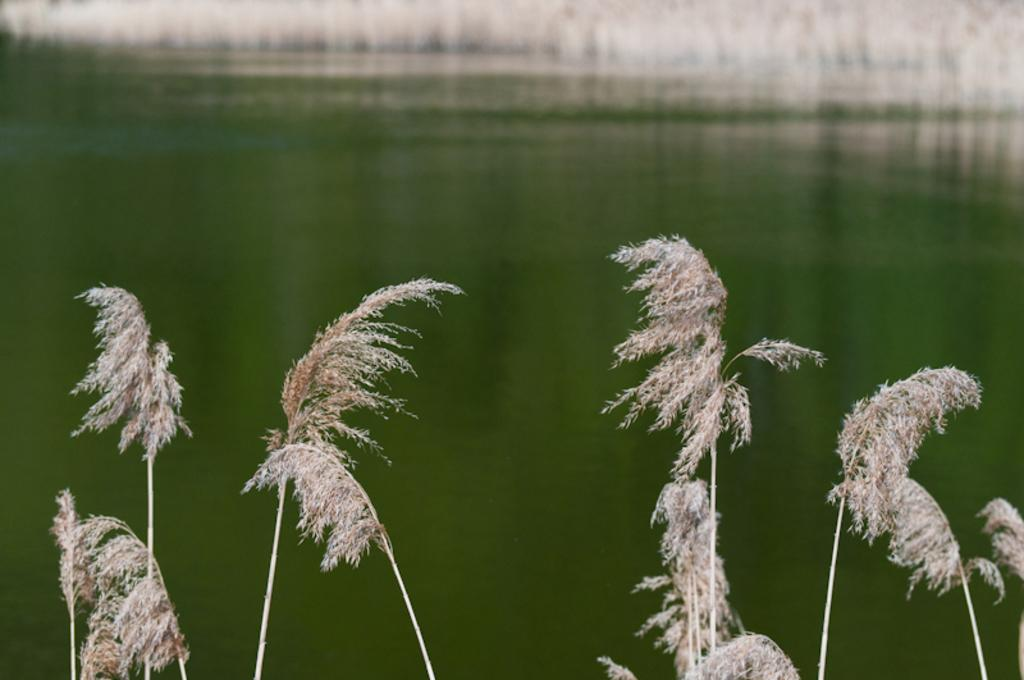What type of living organisms can be seen in the image? Plants can be seen in the image. What colors are the plants in the image? The plants are cream and brown in color. What can be seen in the background of the image? Water and cream-colored objects are visible in the background of the image. What is the color of the water in the image? The water is green in color. What type of education is being provided to the family in the image? There is no family present in the image, and therefore no education is being provided. How much dust can be seen on the plants in the image? There is no dust visible on the plants in the image. 